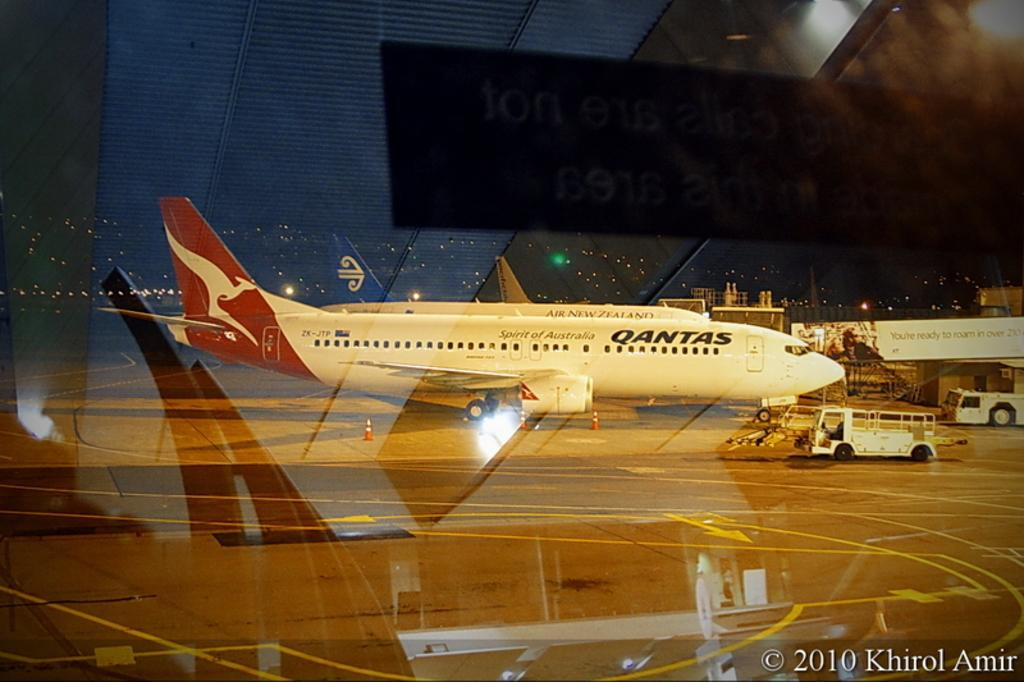Provide a one-sentence caption for the provided image. a Qantas plane at a gate looking from an inside window. 